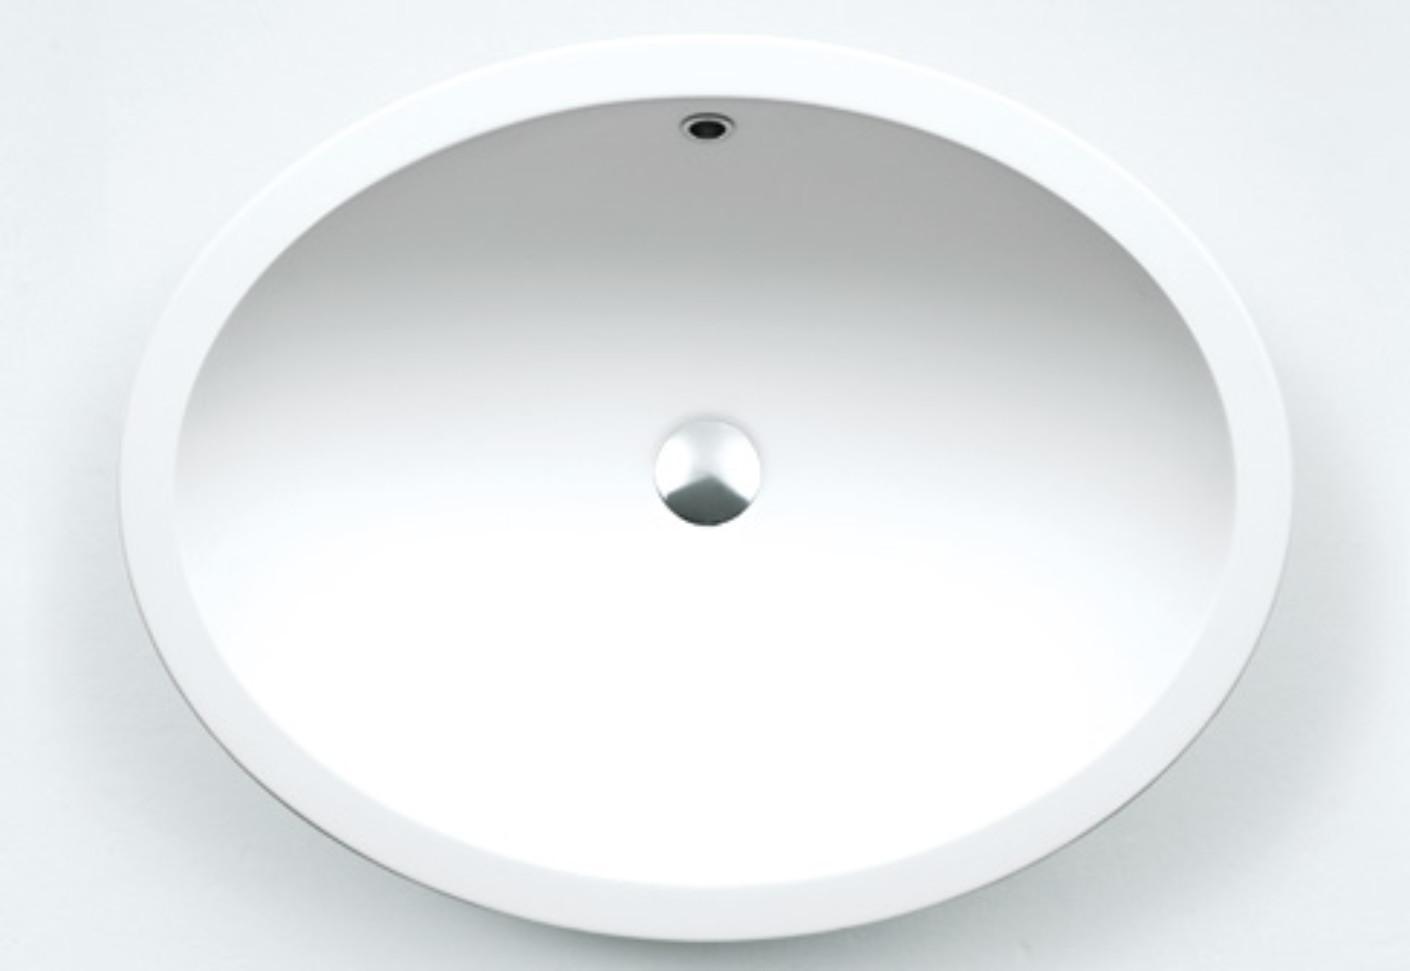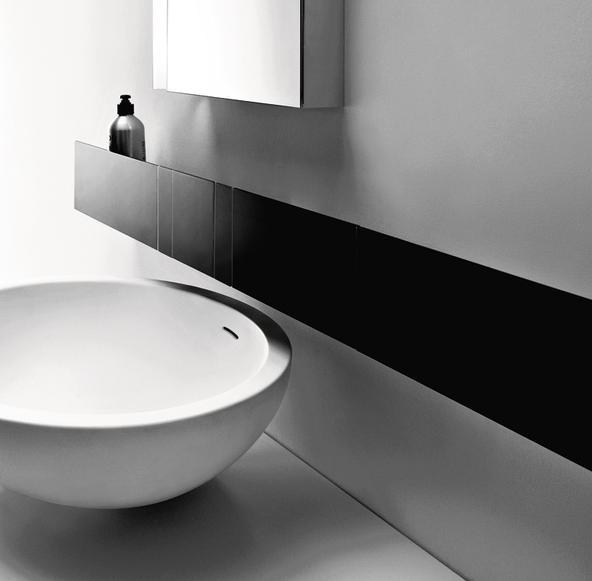The first image is the image on the left, the second image is the image on the right. For the images displayed, is the sentence "There are exactly two faucets." factually correct? Answer yes or no. No. The first image is the image on the left, the second image is the image on the right. Assess this claim about the two images: "The left image features an aerial view of a rounded white uninstalled sink, and the right views shows the same sink shape on a counter under a black ledge with at least one bottle at the end of it.". Correct or not? Answer yes or no. Yes. 